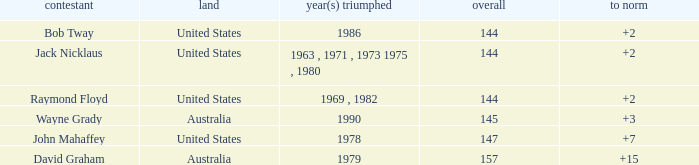How many strokes off par was the winner in 1978? 7.0. 